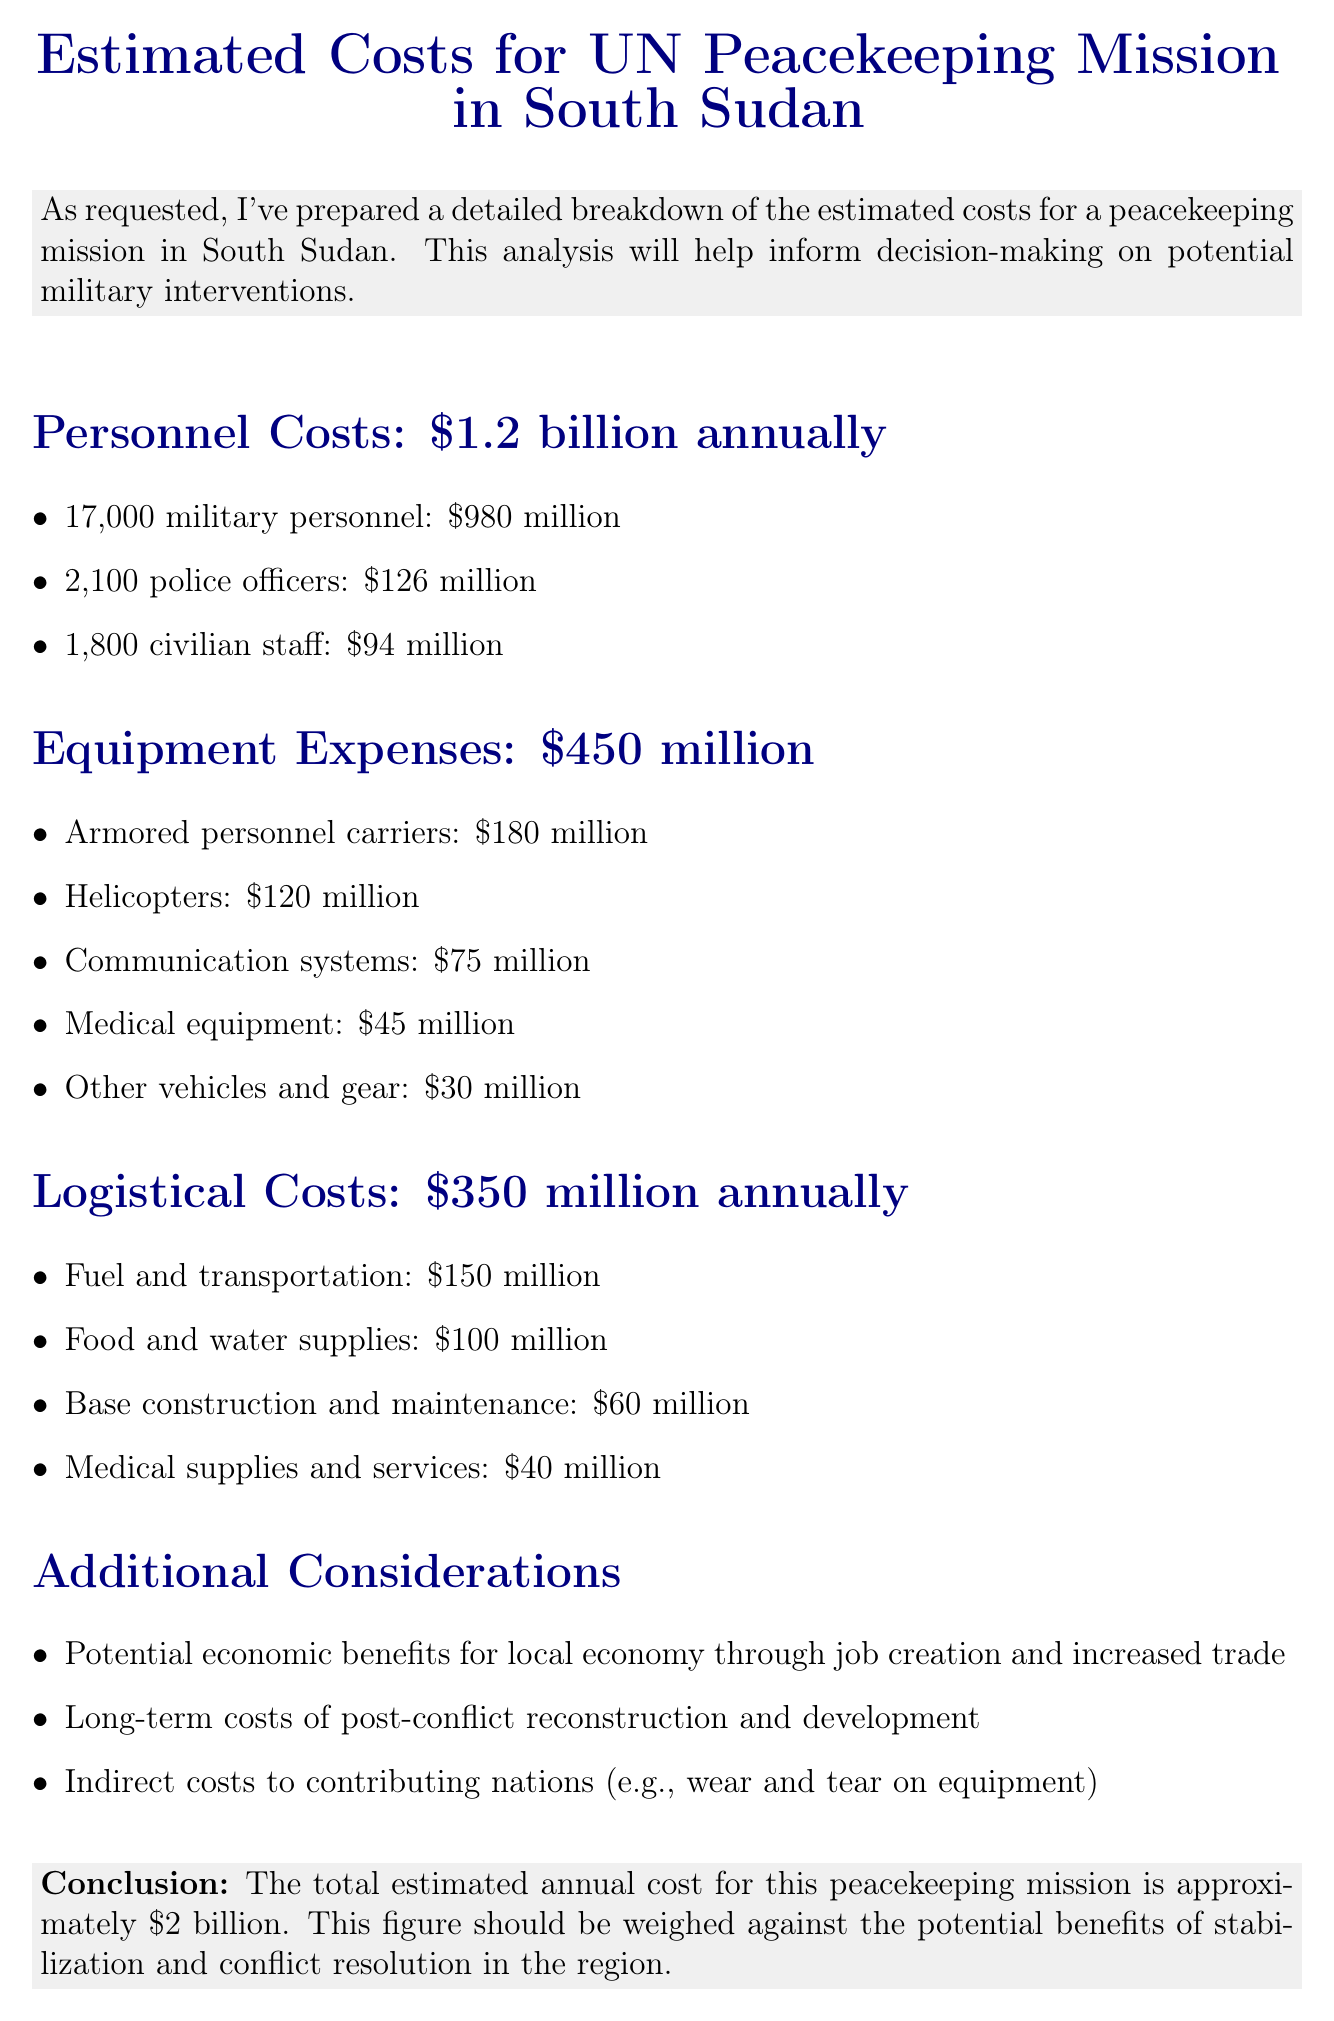What is the total estimated annual cost for the peacekeeping mission? The total estimated annual cost is explicitly mentioned in the conclusion of the document as approximately $2 billion.
Answer: $2 billion How many military personnel are involved? The document provides a specific number of military personnel in the personnel costs section.
Answer: 17,000 What is the cost of medical equipment? The breakdown of equipment expenses lists medical equipment as a specific item with its associated cost.
Answer: $45 million What are the logistical costs for fuel and transportation? The document contains a detailed breakdown of logistical costs, specifically mentioning fuel and transportation.
Answer: $150 million What is the total cost for personnel? The total cost for personnel is summarized in the personnel costs section.
Answer: $1.2 billion annually What potential economic benefit is mentioned? The document highlights a specific potential economic benefit related to job creation and trade under additional considerations.
Answer: Job creation and increased trade What is the cost of armored personnel carriers? The cost of armored personnel carriers is listed as a specific item in the equipment expenses section.
Answer: $180 million What is the total equipment expenses? The total for equipment expenses is clearly provided in the section concerning equipment costs.
Answer: $450 million What category of logistical expenses does base construction fall into? The document categorizes base construction under logistical costs, specifying it in the associated list.
Answer: Logistical costs 